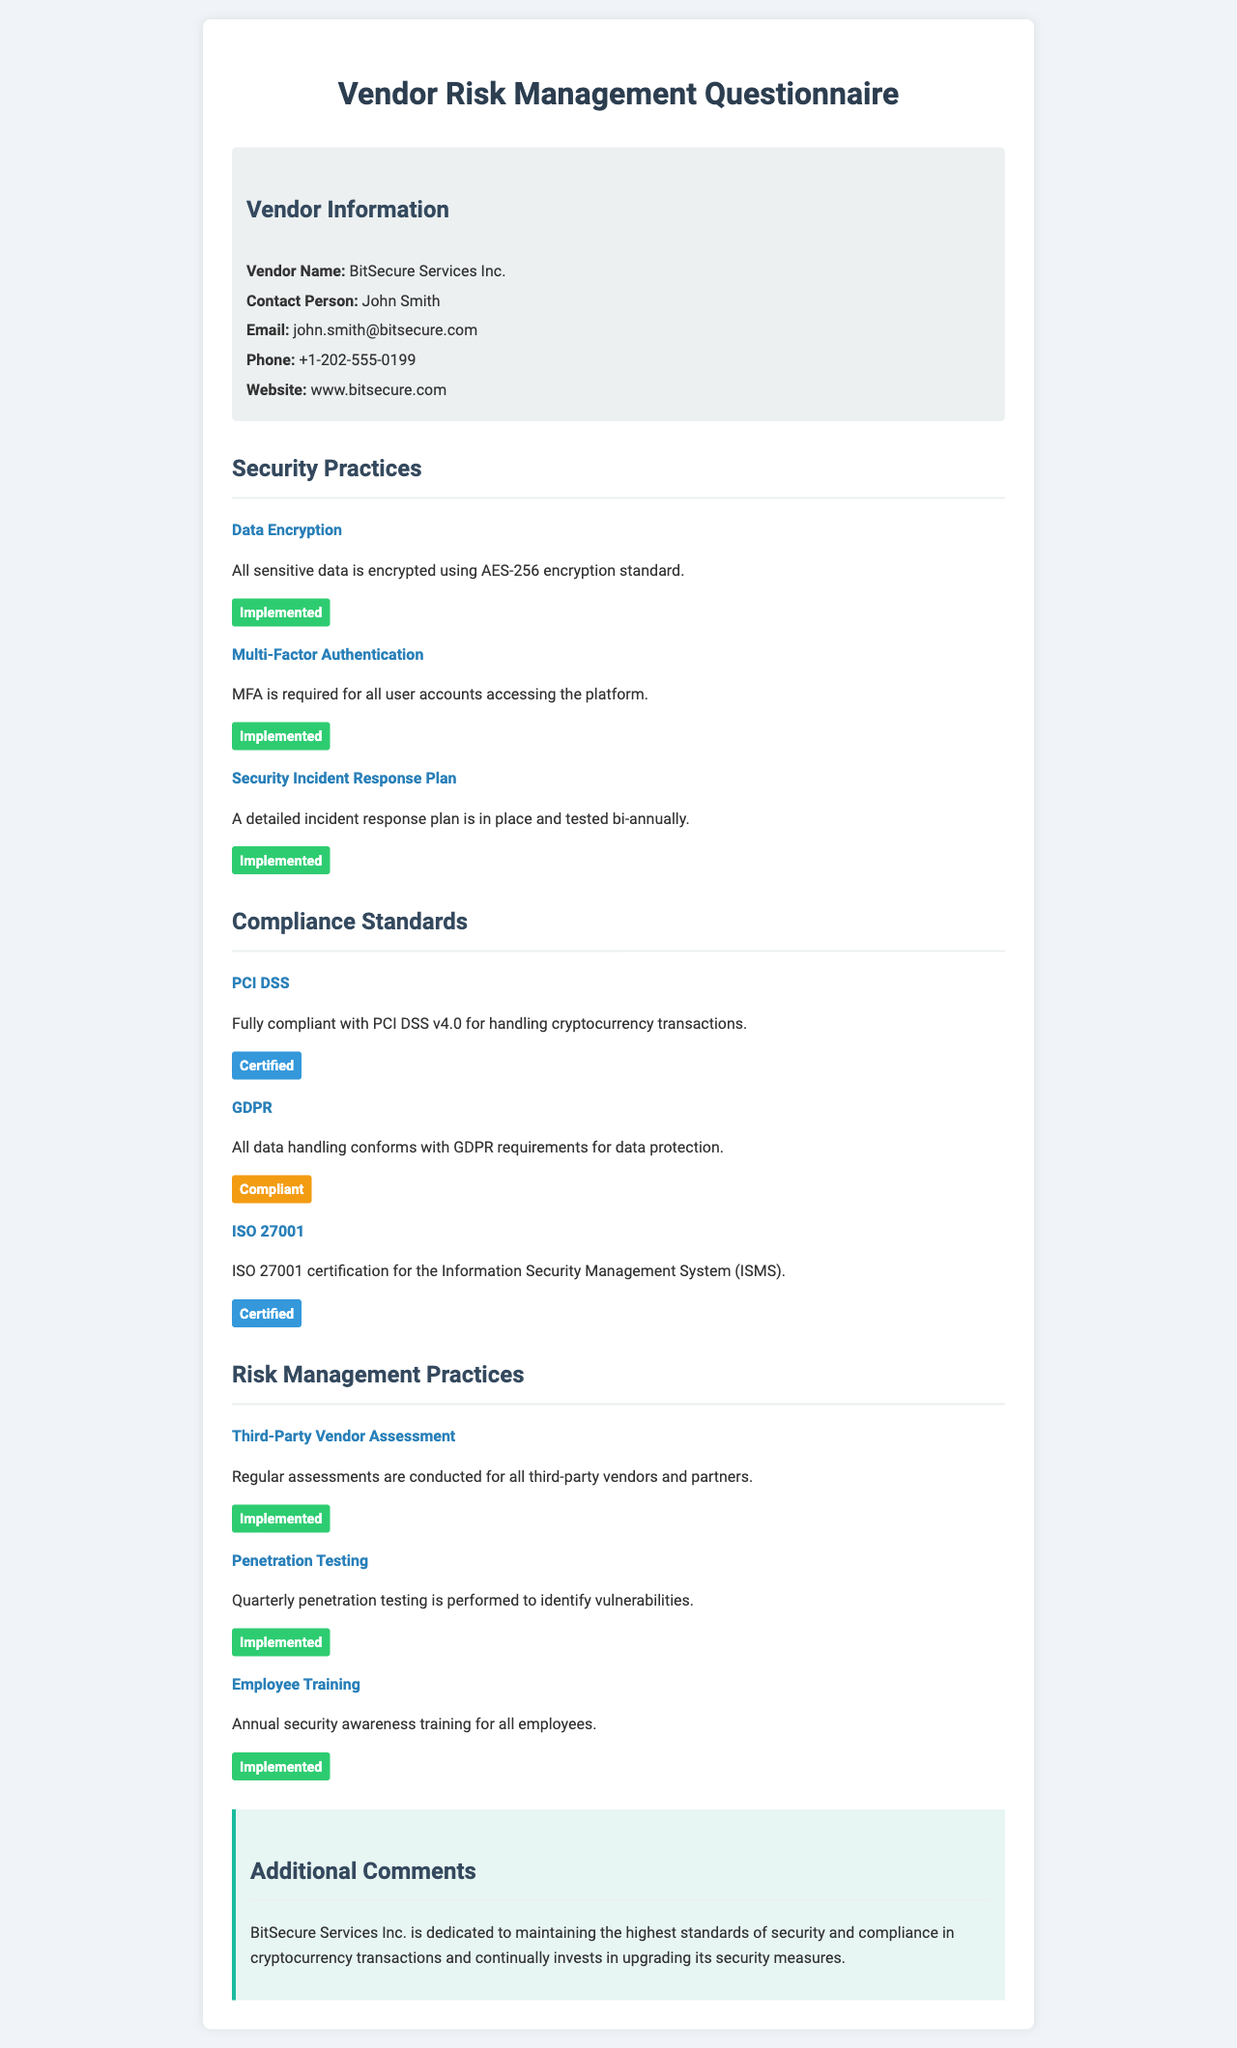What is the vendor name? The vendor name is specified in the document under Vendor Information.
Answer: BitSecure Services Inc Who is the contact person? The document lists the contact person for the vendor under Vendor Information.
Answer: John Smith What encryption standard is used for sensitive data? The document indicates the encryption standard used for sensitive data in the Security Practices section.
Answer: AES-256 How often is penetration testing performed? The document details the frequency of penetration testing in the Risk Management Practices section.
Answer: Quarterly Is BitSecure Services Inc. compliant with GDPR? The document provides information about GDPR compliance in the Compliance Standards section.
Answer: Compliant What certification does BitSecure have for Information Security Management System? The certification related to the Information Security Management System is mentioned in the Compliance Standards section.
Answer: ISO 27001 How frequently is the security incident response plan tested? The document states the testing frequency for the incident response plan in the Security Practices section.
Answer: Bi-annually What type of training is provided to employees? The document describes the type of training offered to employees in the Risk Management Practices section.
Answer: Security awareness training What is the website of the vendor? The vendor's website is provided in the Vendor Information section of the document.
Answer: www.bitsecure.com 